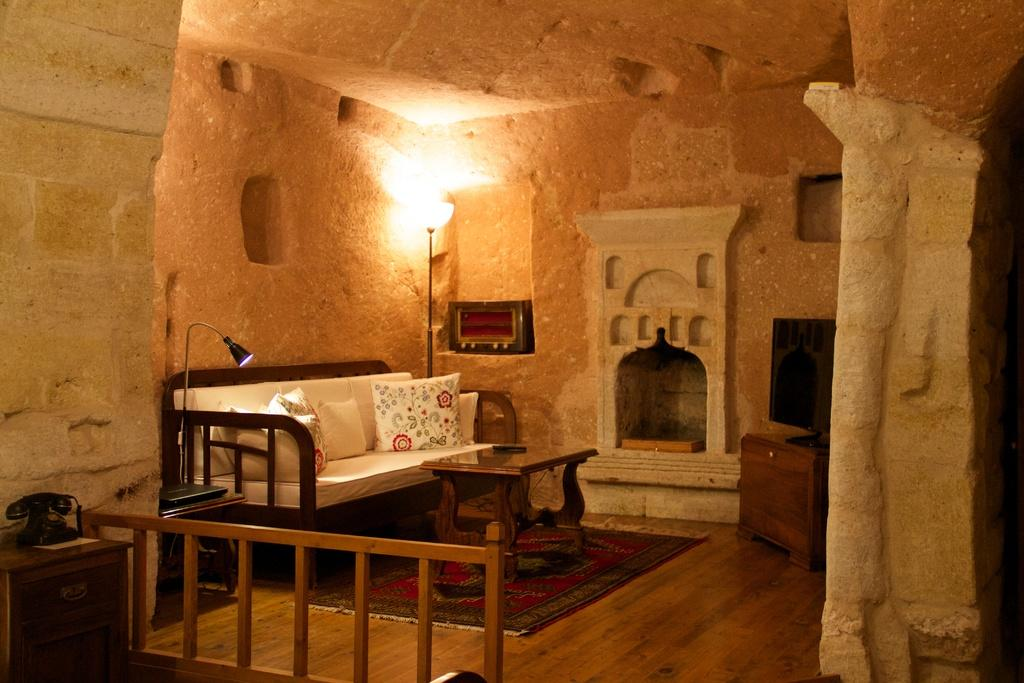What type of furniture is present in the living room? There is a sofa in the living room. What other piece of furniture can be found in the living room? There is a table in the living room. Are there any lighting fixtures in the living room? Yes, there is a lamp in the living room. What architectural feature is present in the living room? There is a chimney in the living room. What type of entertainment device is in the living room? There is a TV in the living room. Can you see any stitches on the sofa in the living room? There is no mention of stitches on the sofa in the image, so it cannot be determined if any are present. 